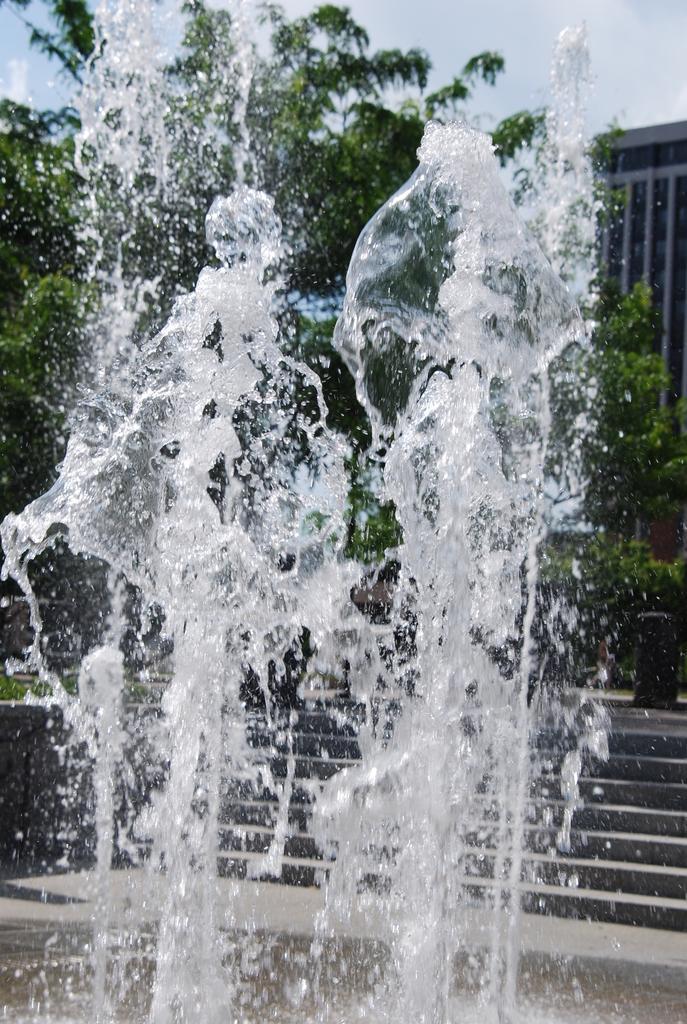In one or two sentences, can you explain what this image depicts? In this picture we can see water, steps, trees, building and in the background we can see the sky with clouds. 